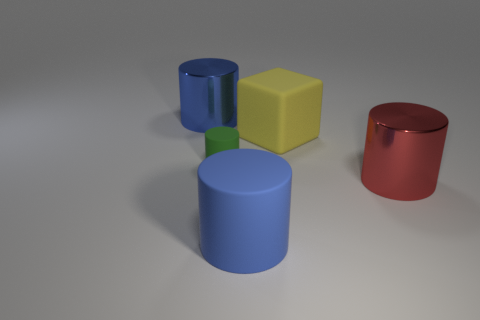Subtract all red cylinders. How many cylinders are left? 3 Subtract all purple balls. How many blue cylinders are left? 2 Subtract all green cylinders. How many cylinders are left? 3 Subtract 1 cylinders. How many cylinders are left? 3 Add 5 red things. How many objects exist? 10 Subtract all cubes. How many objects are left? 4 Subtract all brown objects. Subtract all tiny objects. How many objects are left? 4 Add 1 blue metallic cylinders. How many blue metallic cylinders are left? 2 Add 3 large yellow balls. How many large yellow balls exist? 3 Subtract 0 gray balls. How many objects are left? 5 